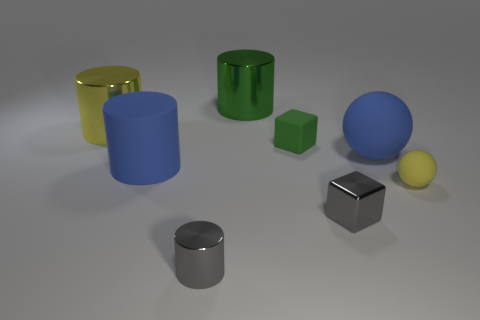Subtract all shiny cylinders. How many cylinders are left? 1 Subtract 1 cylinders. How many cylinders are left? 3 Subtract all blue cylinders. How many cylinders are left? 3 Subtract all brown cylinders. Subtract all brown balls. How many cylinders are left? 4 Add 1 large blue things. How many objects exist? 9 Subtract all balls. How many objects are left? 6 Subtract 0 purple blocks. How many objects are left? 8 Subtract all tiny rubber blocks. Subtract all small red rubber cylinders. How many objects are left? 7 Add 6 green cylinders. How many green cylinders are left? 7 Add 8 large green cylinders. How many large green cylinders exist? 9 